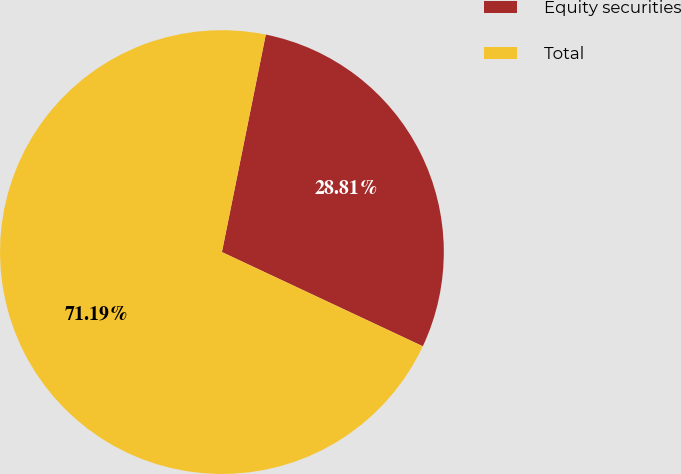Convert chart. <chart><loc_0><loc_0><loc_500><loc_500><pie_chart><fcel>Equity securities<fcel>Total<nl><fcel>28.81%<fcel>71.19%<nl></chart> 